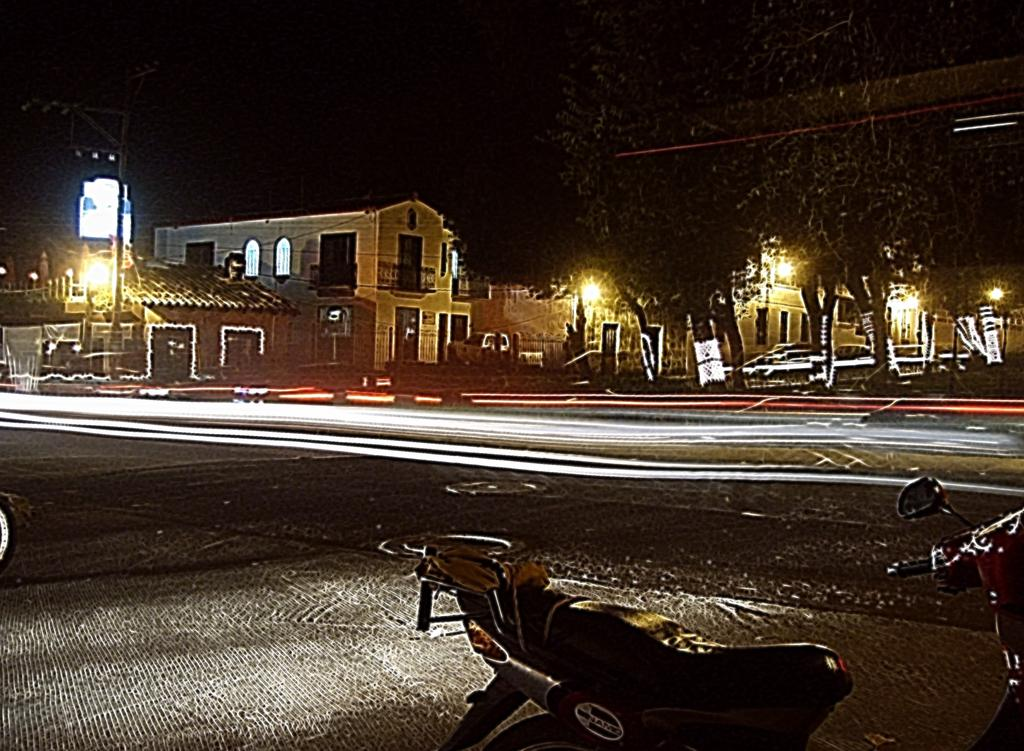What time of day was the image taken? The image was taken at night. What is the main subject in the middle of the image? There is a house in the middle of the image. Can you see any light in the image? Yes, there is light visible in the image. What is located at the bottom of the image? There is a bike at the bottom of the image. What is in the middle of the image besides the house? There is a road in the middle of the image. What type of tooth is visible in the image? There is no tooth present in the image. What print can be seen on the bike in the image? There is no print visible on the bike in the image. 